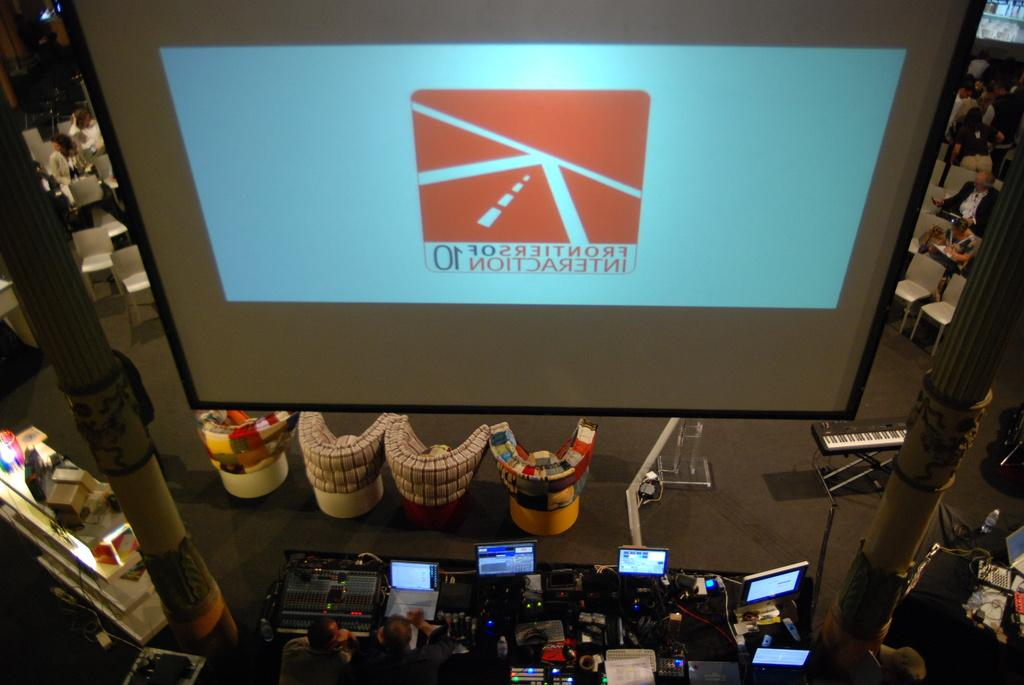<image>
Give a short and clear explanation of the subsequent image. Lettering appears backwards on a screen and has the numbers 01 below a picture of a road. 